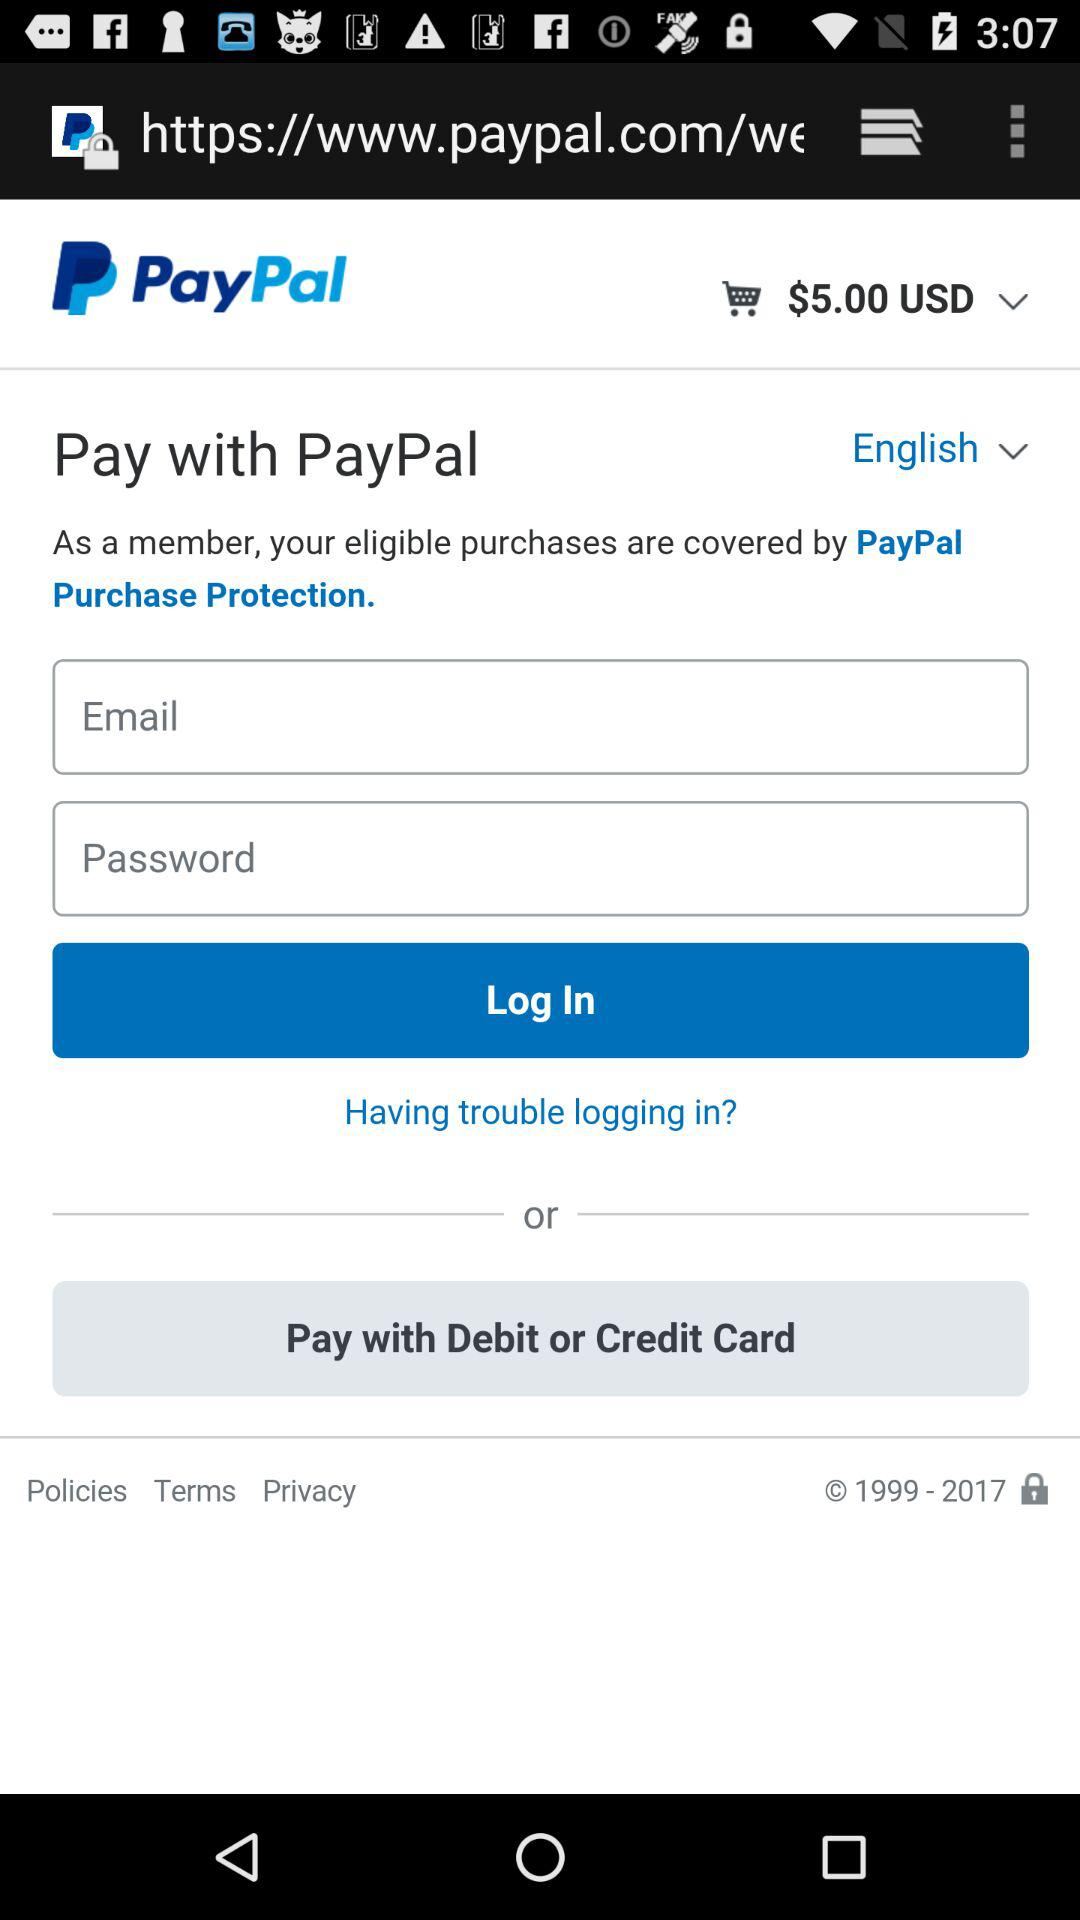What is the amount in the cart? The amount in the cart is $5.00 USD. 